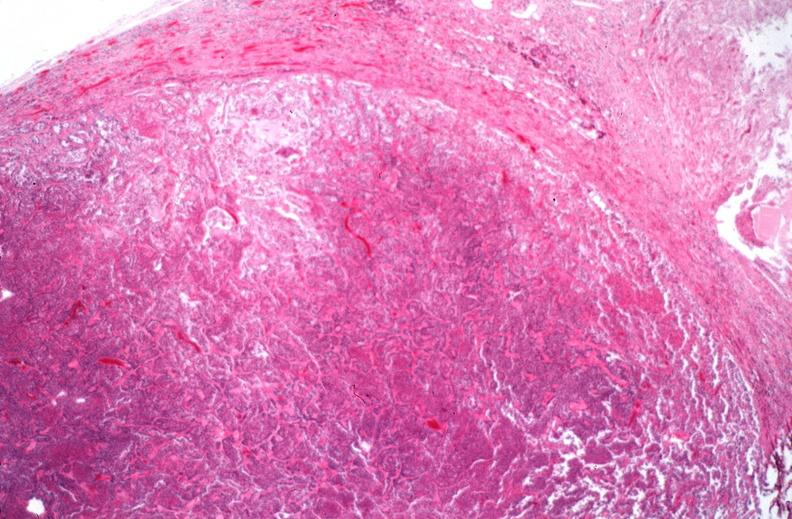s atrophy present?
Answer the question using a single word or phrase. No 